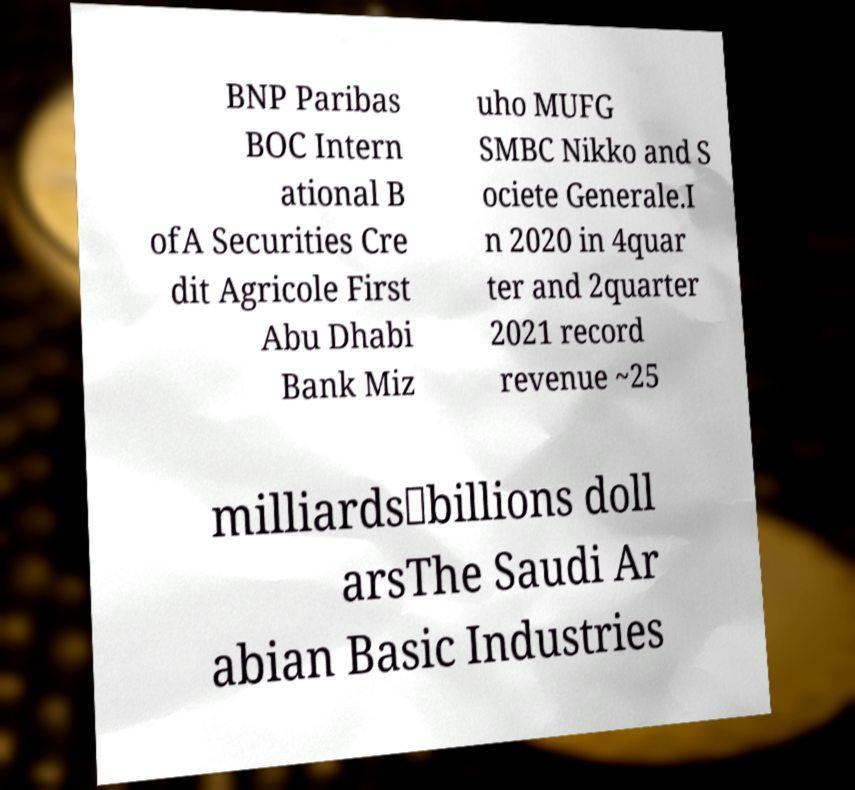Please identify and transcribe the text found in this image. BNP Paribas BOC Intern ational B ofA Securities Cre dit Agricole First Abu Dhabi Bank Miz uho MUFG SMBC Nikko and S ociete Generale.I n 2020 in 4quar ter and 2quarter 2021 record revenue ~25 milliards\billions doll arsThe Saudi Ar abian Basic Industries 